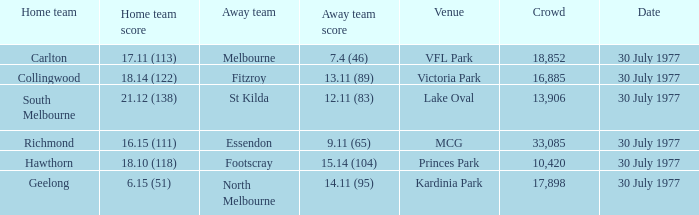What is north melbourne's score as an away side? 14.11 (95). 